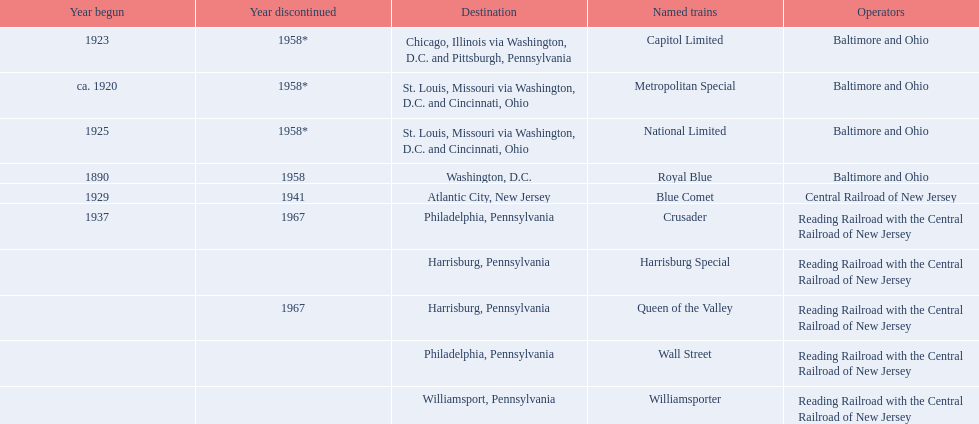What were all of the destinations? Chicago, Illinois via Washington, D.C. and Pittsburgh, Pennsylvania, St. Louis, Missouri via Washington, D.C. and Cincinnati, Ohio, St. Louis, Missouri via Washington, D.C. and Cincinnati, Ohio, Washington, D.C., Atlantic City, New Jersey, Philadelphia, Pennsylvania, Harrisburg, Pennsylvania, Harrisburg, Pennsylvania, Philadelphia, Pennsylvania, Williamsport, Pennsylvania. And what were the names of the trains? Capitol Limited, Metropolitan Special, National Limited, Royal Blue, Blue Comet, Crusader, Harrisburg Special, Queen of the Valley, Wall Street, Williamsporter. Of those, and along with wall street, which train ran to philadelphia, pennsylvania? Crusader. 